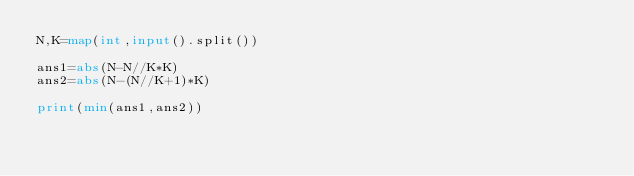Convert code to text. <code><loc_0><loc_0><loc_500><loc_500><_Python_>N,K=map(int,input().split())

ans1=abs(N-N//K*K)
ans2=abs(N-(N//K+1)*K)

print(min(ans1,ans2))</code> 